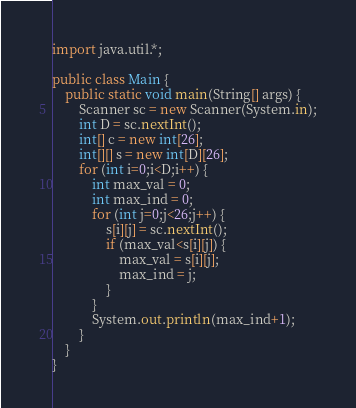Convert code to text. <code><loc_0><loc_0><loc_500><loc_500><_Java_>import java.util.*;

public class Main {
	public static void main(String[] args) {
		Scanner sc = new Scanner(System.in);
		int D = sc.nextInt();
		int[] c = new int[26];
		int[][] s = new int[D][26];
		for (int i=0;i<D;i++) {
			int max_val = 0;
			int max_ind = 0;
			for (int j=0;j<26;j++) {
				s[i][j] = sc.nextInt();
				if (max_val<s[i][j]) {
					max_val = s[i][j];
					max_ind = j;
				}
			}
			System.out.println(max_ind+1);
		}
	}
}</code> 